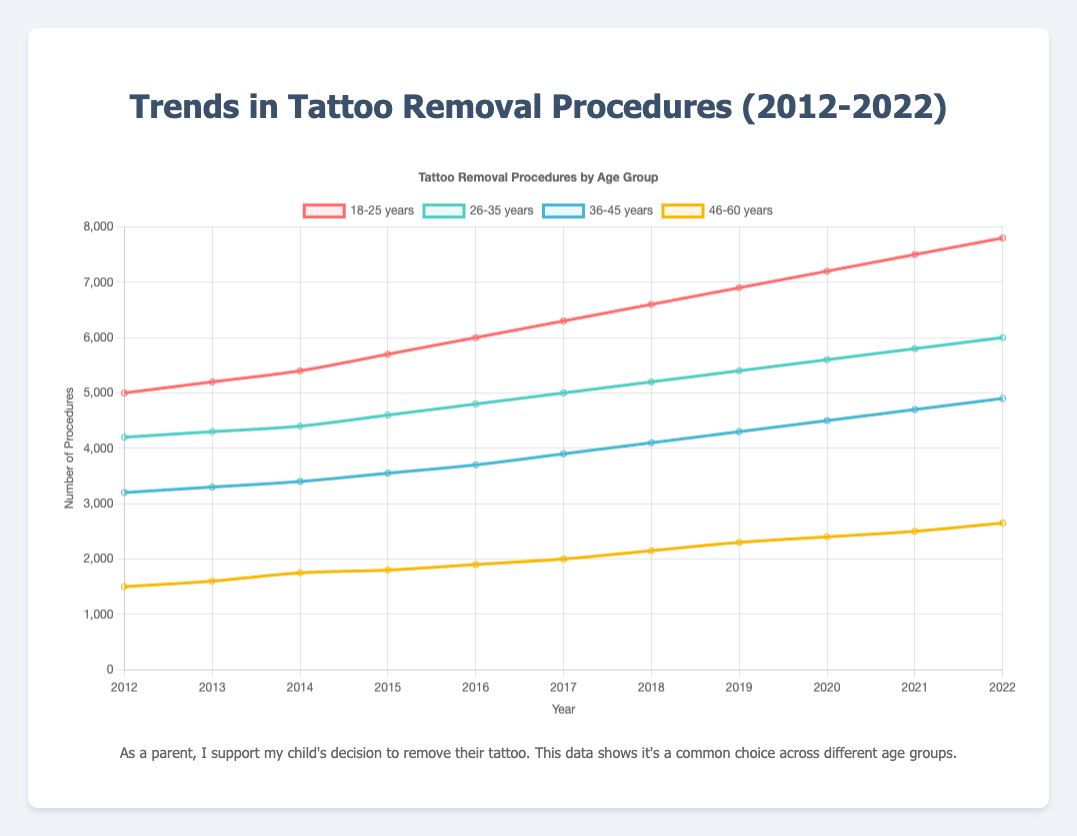How many more tattoo removal procedures were done in 2022 for the age group 18-25 compared to the age group 46-60? Subtract the number of procedures for age group 46-60 (2650) from the number for age group 18-25 (7800), which equals 5150
Answer: 5150 Which age group has shown the highest increase in tattoo removal procedures from 2012 to 2022? Subtract the number of procedures in 2012 from the number in 2022 for each age group, then compare the results. Age group 18-25 increased from 5000 to 7800, which is an increase of 2800, the largest increase among the groups
Answer: Age group 18-25 By how many procedures did the number of tattoo removals for age group 26-35 increase between 2016 and 2020? Subtract the number of procedures in 2016 (4800) from the number in 2020 (5600), which equals 800
Answer: 800 In which year did the age group 36-45 surpass 4000 tattoo removal procedures? Identify the year where the data for age group 36-45 was first above 4000. That occurs in 2018 with 4100 procedures
Answer: 2018 Compare the trends of age group 36-45 and age group 46-60 between 2012 and 2022. Which group had a more consistent year-over-year increase? Calculate the yearly change for each age group. Age group 46-60 shows consistent increases each year by approximately 100 to 200 procedures, while age group 36-45 has a larger but more variable increase. Hence, age group 46-60 shows a more consistent pattern
Answer: Age group 46-60 What was the average yearly number of tattoo removal procedures for the age group 26-35 from 2012 to 2022? Sum the number of procedures from 2012 to 2022 for age group 26-35 (total is 52900), then divide by the number of years (11), which equals approximately 4818
Answer: 4818 Which year had the largest overall total number of tattoo removal procedures across all age groups? Sum the number of procedures for all age groups for each year and compare the totals. 2022 has the highest total with a sum of (7800 + 6000 + 4900 + 2650) = 21350
Answer: 2022 